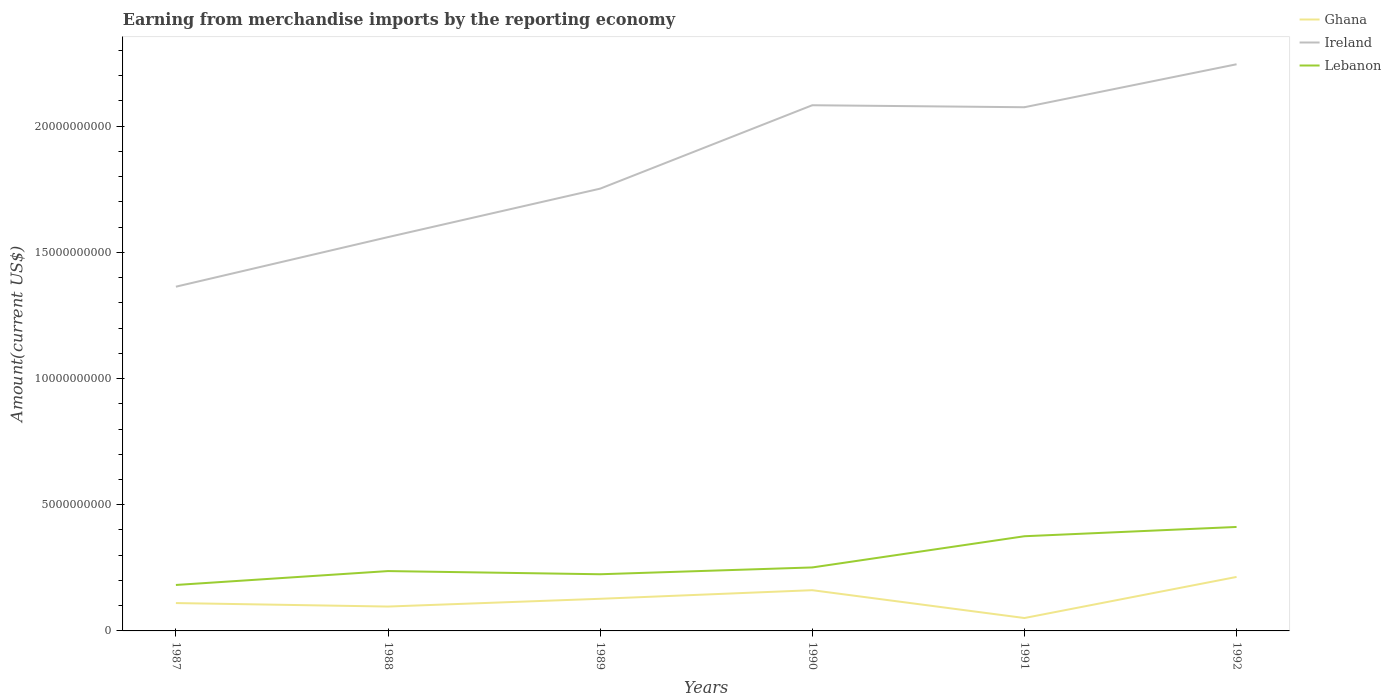How many different coloured lines are there?
Ensure brevity in your answer.  3. Across all years, what is the maximum amount earned from merchandise imports in Ghana?
Offer a very short reply. 5.11e+08. In which year was the amount earned from merchandise imports in Ireland maximum?
Your answer should be very brief. 1987. What is the total amount earned from merchandise imports in Ireland in the graph?
Your answer should be very brief. 7.91e+07. What is the difference between the highest and the second highest amount earned from merchandise imports in Lebanon?
Your response must be concise. 2.30e+09. Is the amount earned from merchandise imports in Ireland strictly greater than the amount earned from merchandise imports in Lebanon over the years?
Your answer should be very brief. No. How many lines are there?
Your response must be concise. 3. How many years are there in the graph?
Ensure brevity in your answer.  6. What is the difference between two consecutive major ticks on the Y-axis?
Give a very brief answer. 5.00e+09. Does the graph contain any zero values?
Make the answer very short. No. Where does the legend appear in the graph?
Make the answer very short. Top right. What is the title of the graph?
Offer a very short reply. Earning from merchandise imports by the reporting economy. Does "Mali" appear as one of the legend labels in the graph?
Offer a terse response. No. What is the label or title of the X-axis?
Provide a short and direct response. Years. What is the label or title of the Y-axis?
Provide a short and direct response. Amount(current US$). What is the Amount(current US$) in Ghana in 1987?
Offer a terse response. 1.10e+09. What is the Amount(current US$) in Ireland in 1987?
Provide a succinct answer. 1.36e+1. What is the Amount(current US$) of Lebanon in 1987?
Make the answer very short. 1.82e+09. What is the Amount(current US$) in Ghana in 1988?
Your answer should be compact. 9.66e+08. What is the Amount(current US$) in Ireland in 1988?
Offer a very short reply. 1.56e+1. What is the Amount(current US$) in Lebanon in 1988?
Ensure brevity in your answer.  2.37e+09. What is the Amount(current US$) in Ghana in 1989?
Offer a very short reply. 1.27e+09. What is the Amount(current US$) in Ireland in 1989?
Provide a succinct answer. 1.75e+1. What is the Amount(current US$) of Lebanon in 1989?
Your response must be concise. 2.25e+09. What is the Amount(current US$) of Ghana in 1990?
Provide a short and direct response. 1.61e+09. What is the Amount(current US$) of Ireland in 1990?
Provide a short and direct response. 2.08e+1. What is the Amount(current US$) of Lebanon in 1990?
Offer a terse response. 2.52e+09. What is the Amount(current US$) in Ghana in 1991?
Give a very brief answer. 5.11e+08. What is the Amount(current US$) of Ireland in 1991?
Make the answer very short. 2.08e+1. What is the Amount(current US$) in Lebanon in 1991?
Your answer should be compact. 3.75e+09. What is the Amount(current US$) in Ghana in 1992?
Offer a terse response. 2.14e+09. What is the Amount(current US$) of Ireland in 1992?
Your answer should be compact. 2.25e+1. What is the Amount(current US$) in Lebanon in 1992?
Offer a very short reply. 4.12e+09. Across all years, what is the maximum Amount(current US$) of Ghana?
Offer a very short reply. 2.14e+09. Across all years, what is the maximum Amount(current US$) in Ireland?
Provide a short and direct response. 2.25e+1. Across all years, what is the maximum Amount(current US$) in Lebanon?
Make the answer very short. 4.12e+09. Across all years, what is the minimum Amount(current US$) of Ghana?
Provide a short and direct response. 5.11e+08. Across all years, what is the minimum Amount(current US$) of Ireland?
Provide a short and direct response. 1.36e+1. Across all years, what is the minimum Amount(current US$) of Lebanon?
Provide a short and direct response. 1.82e+09. What is the total Amount(current US$) of Ghana in the graph?
Keep it short and to the point. 7.61e+09. What is the total Amount(current US$) of Ireland in the graph?
Provide a short and direct response. 1.11e+11. What is the total Amount(current US$) in Lebanon in the graph?
Give a very brief answer. 1.68e+1. What is the difference between the Amount(current US$) in Ghana in 1987 and that in 1988?
Offer a very short reply. 1.38e+08. What is the difference between the Amount(current US$) in Ireland in 1987 and that in 1988?
Your response must be concise. -1.96e+09. What is the difference between the Amount(current US$) in Lebanon in 1987 and that in 1988?
Provide a succinct answer. -5.50e+08. What is the difference between the Amount(current US$) in Ghana in 1987 and that in 1989?
Provide a succinct answer. -1.69e+08. What is the difference between the Amount(current US$) of Ireland in 1987 and that in 1989?
Make the answer very short. -3.89e+09. What is the difference between the Amount(current US$) in Lebanon in 1987 and that in 1989?
Make the answer very short. -4.25e+08. What is the difference between the Amount(current US$) in Ghana in 1987 and that in 1990?
Ensure brevity in your answer.  -5.10e+08. What is the difference between the Amount(current US$) in Ireland in 1987 and that in 1990?
Provide a succinct answer. -7.19e+09. What is the difference between the Amount(current US$) of Lebanon in 1987 and that in 1990?
Make the answer very short. -6.95e+08. What is the difference between the Amount(current US$) of Ghana in 1987 and that in 1991?
Your answer should be very brief. 5.93e+08. What is the difference between the Amount(current US$) of Ireland in 1987 and that in 1991?
Offer a terse response. -7.11e+09. What is the difference between the Amount(current US$) of Lebanon in 1987 and that in 1991?
Give a very brief answer. -1.93e+09. What is the difference between the Amount(current US$) of Ghana in 1987 and that in 1992?
Your answer should be very brief. -1.04e+09. What is the difference between the Amount(current US$) in Ireland in 1987 and that in 1992?
Your response must be concise. -8.81e+09. What is the difference between the Amount(current US$) of Lebanon in 1987 and that in 1992?
Your response must be concise. -2.30e+09. What is the difference between the Amount(current US$) in Ghana in 1988 and that in 1989?
Provide a succinct answer. -3.08e+08. What is the difference between the Amount(current US$) in Ireland in 1988 and that in 1989?
Provide a succinct answer. -1.92e+09. What is the difference between the Amount(current US$) of Lebanon in 1988 and that in 1989?
Offer a very short reply. 1.25e+08. What is the difference between the Amount(current US$) in Ghana in 1988 and that in 1990?
Keep it short and to the point. -6.48e+08. What is the difference between the Amount(current US$) of Ireland in 1988 and that in 1990?
Your answer should be very brief. -5.23e+09. What is the difference between the Amount(current US$) in Lebanon in 1988 and that in 1990?
Offer a very short reply. -1.44e+08. What is the difference between the Amount(current US$) in Ghana in 1988 and that in 1991?
Make the answer very short. 4.54e+08. What is the difference between the Amount(current US$) of Ireland in 1988 and that in 1991?
Your response must be concise. -5.15e+09. What is the difference between the Amount(current US$) of Lebanon in 1988 and that in 1991?
Offer a terse response. -1.38e+09. What is the difference between the Amount(current US$) in Ghana in 1988 and that in 1992?
Make the answer very short. -1.17e+09. What is the difference between the Amount(current US$) of Ireland in 1988 and that in 1992?
Offer a terse response. -6.85e+09. What is the difference between the Amount(current US$) of Lebanon in 1988 and that in 1992?
Provide a short and direct response. -1.75e+09. What is the difference between the Amount(current US$) in Ghana in 1989 and that in 1990?
Provide a succinct answer. -3.41e+08. What is the difference between the Amount(current US$) in Ireland in 1989 and that in 1990?
Provide a short and direct response. -3.31e+09. What is the difference between the Amount(current US$) in Lebanon in 1989 and that in 1990?
Give a very brief answer. -2.70e+08. What is the difference between the Amount(current US$) in Ghana in 1989 and that in 1991?
Provide a short and direct response. 7.62e+08. What is the difference between the Amount(current US$) of Ireland in 1989 and that in 1991?
Ensure brevity in your answer.  -3.23e+09. What is the difference between the Amount(current US$) of Lebanon in 1989 and that in 1991?
Offer a terse response. -1.51e+09. What is the difference between the Amount(current US$) in Ghana in 1989 and that in 1992?
Keep it short and to the point. -8.66e+08. What is the difference between the Amount(current US$) of Ireland in 1989 and that in 1992?
Keep it short and to the point. -4.93e+09. What is the difference between the Amount(current US$) of Lebanon in 1989 and that in 1992?
Provide a short and direct response. -1.87e+09. What is the difference between the Amount(current US$) in Ghana in 1990 and that in 1991?
Make the answer very short. 1.10e+09. What is the difference between the Amount(current US$) of Ireland in 1990 and that in 1991?
Ensure brevity in your answer.  7.91e+07. What is the difference between the Amount(current US$) of Lebanon in 1990 and that in 1991?
Offer a terse response. -1.24e+09. What is the difference between the Amount(current US$) of Ghana in 1990 and that in 1992?
Your answer should be compact. -5.25e+08. What is the difference between the Amount(current US$) of Ireland in 1990 and that in 1992?
Keep it short and to the point. -1.62e+09. What is the difference between the Amount(current US$) of Lebanon in 1990 and that in 1992?
Make the answer very short. -1.60e+09. What is the difference between the Amount(current US$) of Ghana in 1991 and that in 1992?
Your answer should be compact. -1.63e+09. What is the difference between the Amount(current US$) in Ireland in 1991 and that in 1992?
Your answer should be very brief. -1.70e+09. What is the difference between the Amount(current US$) in Lebanon in 1991 and that in 1992?
Your answer should be compact. -3.68e+08. What is the difference between the Amount(current US$) of Ghana in 1987 and the Amount(current US$) of Ireland in 1988?
Provide a short and direct response. -1.45e+1. What is the difference between the Amount(current US$) of Ghana in 1987 and the Amount(current US$) of Lebanon in 1988?
Give a very brief answer. -1.27e+09. What is the difference between the Amount(current US$) of Ireland in 1987 and the Amount(current US$) of Lebanon in 1988?
Ensure brevity in your answer.  1.13e+1. What is the difference between the Amount(current US$) of Ghana in 1987 and the Amount(current US$) of Ireland in 1989?
Provide a short and direct response. -1.64e+1. What is the difference between the Amount(current US$) of Ghana in 1987 and the Amount(current US$) of Lebanon in 1989?
Your answer should be compact. -1.14e+09. What is the difference between the Amount(current US$) in Ireland in 1987 and the Amount(current US$) in Lebanon in 1989?
Offer a terse response. 1.14e+1. What is the difference between the Amount(current US$) in Ghana in 1987 and the Amount(current US$) in Ireland in 1990?
Give a very brief answer. -1.97e+1. What is the difference between the Amount(current US$) in Ghana in 1987 and the Amount(current US$) in Lebanon in 1990?
Your answer should be compact. -1.41e+09. What is the difference between the Amount(current US$) in Ireland in 1987 and the Amount(current US$) in Lebanon in 1990?
Offer a terse response. 1.11e+1. What is the difference between the Amount(current US$) of Ghana in 1987 and the Amount(current US$) of Ireland in 1991?
Provide a succinct answer. -1.96e+1. What is the difference between the Amount(current US$) of Ghana in 1987 and the Amount(current US$) of Lebanon in 1991?
Offer a very short reply. -2.65e+09. What is the difference between the Amount(current US$) in Ireland in 1987 and the Amount(current US$) in Lebanon in 1991?
Keep it short and to the point. 9.89e+09. What is the difference between the Amount(current US$) of Ghana in 1987 and the Amount(current US$) of Ireland in 1992?
Keep it short and to the point. -2.13e+1. What is the difference between the Amount(current US$) of Ghana in 1987 and the Amount(current US$) of Lebanon in 1992?
Offer a very short reply. -3.02e+09. What is the difference between the Amount(current US$) in Ireland in 1987 and the Amount(current US$) in Lebanon in 1992?
Keep it short and to the point. 9.52e+09. What is the difference between the Amount(current US$) of Ghana in 1988 and the Amount(current US$) of Ireland in 1989?
Offer a very short reply. -1.66e+1. What is the difference between the Amount(current US$) of Ghana in 1988 and the Amount(current US$) of Lebanon in 1989?
Offer a terse response. -1.28e+09. What is the difference between the Amount(current US$) in Ireland in 1988 and the Amount(current US$) in Lebanon in 1989?
Give a very brief answer. 1.34e+1. What is the difference between the Amount(current US$) of Ghana in 1988 and the Amount(current US$) of Ireland in 1990?
Offer a very short reply. -1.99e+1. What is the difference between the Amount(current US$) in Ghana in 1988 and the Amount(current US$) in Lebanon in 1990?
Offer a terse response. -1.55e+09. What is the difference between the Amount(current US$) of Ireland in 1988 and the Amount(current US$) of Lebanon in 1990?
Your response must be concise. 1.31e+1. What is the difference between the Amount(current US$) in Ghana in 1988 and the Amount(current US$) in Ireland in 1991?
Your response must be concise. -1.98e+1. What is the difference between the Amount(current US$) in Ghana in 1988 and the Amount(current US$) in Lebanon in 1991?
Provide a short and direct response. -2.79e+09. What is the difference between the Amount(current US$) in Ireland in 1988 and the Amount(current US$) in Lebanon in 1991?
Provide a short and direct response. 1.19e+1. What is the difference between the Amount(current US$) of Ghana in 1988 and the Amount(current US$) of Ireland in 1992?
Provide a succinct answer. -2.15e+1. What is the difference between the Amount(current US$) of Ghana in 1988 and the Amount(current US$) of Lebanon in 1992?
Provide a short and direct response. -3.15e+09. What is the difference between the Amount(current US$) of Ireland in 1988 and the Amount(current US$) of Lebanon in 1992?
Give a very brief answer. 1.15e+1. What is the difference between the Amount(current US$) in Ghana in 1989 and the Amount(current US$) in Ireland in 1990?
Make the answer very short. -1.96e+1. What is the difference between the Amount(current US$) of Ghana in 1989 and the Amount(current US$) of Lebanon in 1990?
Ensure brevity in your answer.  -1.24e+09. What is the difference between the Amount(current US$) of Ireland in 1989 and the Amount(current US$) of Lebanon in 1990?
Ensure brevity in your answer.  1.50e+1. What is the difference between the Amount(current US$) of Ghana in 1989 and the Amount(current US$) of Ireland in 1991?
Give a very brief answer. -1.95e+1. What is the difference between the Amount(current US$) of Ghana in 1989 and the Amount(current US$) of Lebanon in 1991?
Provide a succinct answer. -2.48e+09. What is the difference between the Amount(current US$) in Ireland in 1989 and the Amount(current US$) in Lebanon in 1991?
Offer a terse response. 1.38e+1. What is the difference between the Amount(current US$) in Ghana in 1989 and the Amount(current US$) in Ireland in 1992?
Provide a short and direct response. -2.12e+1. What is the difference between the Amount(current US$) in Ghana in 1989 and the Amount(current US$) in Lebanon in 1992?
Provide a succinct answer. -2.85e+09. What is the difference between the Amount(current US$) of Ireland in 1989 and the Amount(current US$) of Lebanon in 1992?
Your answer should be very brief. 1.34e+1. What is the difference between the Amount(current US$) in Ghana in 1990 and the Amount(current US$) in Ireland in 1991?
Your answer should be very brief. -1.91e+1. What is the difference between the Amount(current US$) of Ghana in 1990 and the Amount(current US$) of Lebanon in 1991?
Ensure brevity in your answer.  -2.14e+09. What is the difference between the Amount(current US$) of Ireland in 1990 and the Amount(current US$) of Lebanon in 1991?
Ensure brevity in your answer.  1.71e+1. What is the difference between the Amount(current US$) of Ghana in 1990 and the Amount(current US$) of Ireland in 1992?
Ensure brevity in your answer.  -2.08e+1. What is the difference between the Amount(current US$) of Ghana in 1990 and the Amount(current US$) of Lebanon in 1992?
Provide a succinct answer. -2.51e+09. What is the difference between the Amount(current US$) in Ireland in 1990 and the Amount(current US$) in Lebanon in 1992?
Keep it short and to the point. 1.67e+1. What is the difference between the Amount(current US$) of Ghana in 1991 and the Amount(current US$) of Ireland in 1992?
Make the answer very short. -2.19e+1. What is the difference between the Amount(current US$) in Ghana in 1991 and the Amount(current US$) in Lebanon in 1992?
Make the answer very short. -3.61e+09. What is the difference between the Amount(current US$) in Ireland in 1991 and the Amount(current US$) in Lebanon in 1992?
Your answer should be very brief. 1.66e+1. What is the average Amount(current US$) in Ghana per year?
Offer a terse response. 1.27e+09. What is the average Amount(current US$) of Ireland per year?
Provide a succinct answer. 1.85e+1. What is the average Amount(current US$) in Lebanon per year?
Your response must be concise. 2.80e+09. In the year 1987, what is the difference between the Amount(current US$) of Ghana and Amount(current US$) of Ireland?
Keep it short and to the point. -1.25e+1. In the year 1987, what is the difference between the Amount(current US$) of Ghana and Amount(current US$) of Lebanon?
Your answer should be compact. -7.17e+08. In the year 1987, what is the difference between the Amount(current US$) of Ireland and Amount(current US$) of Lebanon?
Your answer should be very brief. 1.18e+1. In the year 1988, what is the difference between the Amount(current US$) of Ghana and Amount(current US$) of Ireland?
Provide a succinct answer. -1.46e+1. In the year 1988, what is the difference between the Amount(current US$) of Ghana and Amount(current US$) of Lebanon?
Give a very brief answer. -1.41e+09. In the year 1988, what is the difference between the Amount(current US$) in Ireland and Amount(current US$) in Lebanon?
Offer a very short reply. 1.32e+1. In the year 1989, what is the difference between the Amount(current US$) of Ghana and Amount(current US$) of Ireland?
Provide a short and direct response. -1.63e+1. In the year 1989, what is the difference between the Amount(current US$) of Ghana and Amount(current US$) of Lebanon?
Your answer should be very brief. -9.72e+08. In the year 1989, what is the difference between the Amount(current US$) of Ireland and Amount(current US$) of Lebanon?
Ensure brevity in your answer.  1.53e+1. In the year 1990, what is the difference between the Amount(current US$) in Ghana and Amount(current US$) in Ireland?
Provide a succinct answer. -1.92e+1. In the year 1990, what is the difference between the Amount(current US$) in Ghana and Amount(current US$) in Lebanon?
Offer a very short reply. -9.01e+08. In the year 1990, what is the difference between the Amount(current US$) in Ireland and Amount(current US$) in Lebanon?
Your answer should be very brief. 1.83e+1. In the year 1991, what is the difference between the Amount(current US$) in Ghana and Amount(current US$) in Ireland?
Make the answer very short. -2.02e+1. In the year 1991, what is the difference between the Amount(current US$) of Ghana and Amount(current US$) of Lebanon?
Offer a very short reply. -3.24e+09. In the year 1991, what is the difference between the Amount(current US$) in Ireland and Amount(current US$) in Lebanon?
Offer a very short reply. 1.70e+1. In the year 1992, what is the difference between the Amount(current US$) in Ghana and Amount(current US$) in Ireland?
Your response must be concise. -2.03e+1. In the year 1992, what is the difference between the Amount(current US$) in Ghana and Amount(current US$) in Lebanon?
Offer a terse response. -1.98e+09. In the year 1992, what is the difference between the Amount(current US$) of Ireland and Amount(current US$) of Lebanon?
Ensure brevity in your answer.  1.83e+1. What is the ratio of the Amount(current US$) in Ghana in 1987 to that in 1988?
Keep it short and to the point. 1.14. What is the ratio of the Amount(current US$) in Ireland in 1987 to that in 1988?
Keep it short and to the point. 0.87. What is the ratio of the Amount(current US$) of Lebanon in 1987 to that in 1988?
Your answer should be compact. 0.77. What is the ratio of the Amount(current US$) in Ghana in 1987 to that in 1989?
Provide a short and direct response. 0.87. What is the ratio of the Amount(current US$) in Ireland in 1987 to that in 1989?
Offer a terse response. 0.78. What is the ratio of the Amount(current US$) in Lebanon in 1987 to that in 1989?
Your response must be concise. 0.81. What is the ratio of the Amount(current US$) in Ghana in 1987 to that in 1990?
Keep it short and to the point. 0.68. What is the ratio of the Amount(current US$) of Ireland in 1987 to that in 1990?
Make the answer very short. 0.65. What is the ratio of the Amount(current US$) of Lebanon in 1987 to that in 1990?
Make the answer very short. 0.72. What is the ratio of the Amount(current US$) in Ghana in 1987 to that in 1991?
Give a very brief answer. 2.16. What is the ratio of the Amount(current US$) in Ireland in 1987 to that in 1991?
Make the answer very short. 0.66. What is the ratio of the Amount(current US$) of Lebanon in 1987 to that in 1991?
Ensure brevity in your answer.  0.49. What is the ratio of the Amount(current US$) in Ghana in 1987 to that in 1992?
Your answer should be very brief. 0.52. What is the ratio of the Amount(current US$) of Ireland in 1987 to that in 1992?
Your answer should be very brief. 0.61. What is the ratio of the Amount(current US$) in Lebanon in 1987 to that in 1992?
Keep it short and to the point. 0.44. What is the ratio of the Amount(current US$) in Ghana in 1988 to that in 1989?
Offer a very short reply. 0.76. What is the ratio of the Amount(current US$) of Ireland in 1988 to that in 1989?
Your response must be concise. 0.89. What is the ratio of the Amount(current US$) of Lebanon in 1988 to that in 1989?
Ensure brevity in your answer.  1.06. What is the ratio of the Amount(current US$) of Ghana in 1988 to that in 1990?
Provide a succinct answer. 0.6. What is the ratio of the Amount(current US$) in Ireland in 1988 to that in 1990?
Provide a succinct answer. 0.75. What is the ratio of the Amount(current US$) in Lebanon in 1988 to that in 1990?
Ensure brevity in your answer.  0.94. What is the ratio of the Amount(current US$) of Ghana in 1988 to that in 1991?
Give a very brief answer. 1.89. What is the ratio of the Amount(current US$) of Ireland in 1988 to that in 1991?
Keep it short and to the point. 0.75. What is the ratio of the Amount(current US$) in Lebanon in 1988 to that in 1991?
Keep it short and to the point. 0.63. What is the ratio of the Amount(current US$) of Ghana in 1988 to that in 1992?
Your answer should be very brief. 0.45. What is the ratio of the Amount(current US$) in Ireland in 1988 to that in 1992?
Offer a very short reply. 0.69. What is the ratio of the Amount(current US$) in Lebanon in 1988 to that in 1992?
Ensure brevity in your answer.  0.58. What is the ratio of the Amount(current US$) in Ghana in 1989 to that in 1990?
Provide a succinct answer. 0.79. What is the ratio of the Amount(current US$) in Ireland in 1989 to that in 1990?
Your answer should be compact. 0.84. What is the ratio of the Amount(current US$) of Lebanon in 1989 to that in 1990?
Offer a very short reply. 0.89. What is the ratio of the Amount(current US$) in Ghana in 1989 to that in 1991?
Give a very brief answer. 2.49. What is the ratio of the Amount(current US$) in Ireland in 1989 to that in 1991?
Make the answer very short. 0.84. What is the ratio of the Amount(current US$) in Lebanon in 1989 to that in 1991?
Offer a terse response. 0.6. What is the ratio of the Amount(current US$) of Ghana in 1989 to that in 1992?
Your answer should be very brief. 0.6. What is the ratio of the Amount(current US$) in Ireland in 1989 to that in 1992?
Your answer should be very brief. 0.78. What is the ratio of the Amount(current US$) of Lebanon in 1989 to that in 1992?
Your response must be concise. 0.55. What is the ratio of the Amount(current US$) of Ghana in 1990 to that in 1991?
Give a very brief answer. 3.16. What is the ratio of the Amount(current US$) of Ireland in 1990 to that in 1991?
Make the answer very short. 1. What is the ratio of the Amount(current US$) in Lebanon in 1990 to that in 1991?
Offer a terse response. 0.67. What is the ratio of the Amount(current US$) in Ghana in 1990 to that in 1992?
Provide a succinct answer. 0.75. What is the ratio of the Amount(current US$) of Ireland in 1990 to that in 1992?
Ensure brevity in your answer.  0.93. What is the ratio of the Amount(current US$) of Lebanon in 1990 to that in 1992?
Offer a terse response. 0.61. What is the ratio of the Amount(current US$) of Ghana in 1991 to that in 1992?
Your response must be concise. 0.24. What is the ratio of the Amount(current US$) of Ireland in 1991 to that in 1992?
Provide a succinct answer. 0.92. What is the ratio of the Amount(current US$) in Lebanon in 1991 to that in 1992?
Ensure brevity in your answer.  0.91. What is the difference between the highest and the second highest Amount(current US$) in Ghana?
Your answer should be compact. 5.25e+08. What is the difference between the highest and the second highest Amount(current US$) in Ireland?
Make the answer very short. 1.62e+09. What is the difference between the highest and the second highest Amount(current US$) in Lebanon?
Give a very brief answer. 3.68e+08. What is the difference between the highest and the lowest Amount(current US$) in Ghana?
Keep it short and to the point. 1.63e+09. What is the difference between the highest and the lowest Amount(current US$) of Ireland?
Your response must be concise. 8.81e+09. What is the difference between the highest and the lowest Amount(current US$) of Lebanon?
Your answer should be very brief. 2.30e+09. 